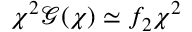<formula> <loc_0><loc_0><loc_500><loc_500>\chi ^ { 2 } \mathcal { G } ( \chi ) \simeq f _ { 2 } \chi ^ { 2 }</formula> 